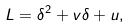<formula> <loc_0><loc_0><loc_500><loc_500>L = \delta ^ { 2 } + v \delta + u ,</formula> 